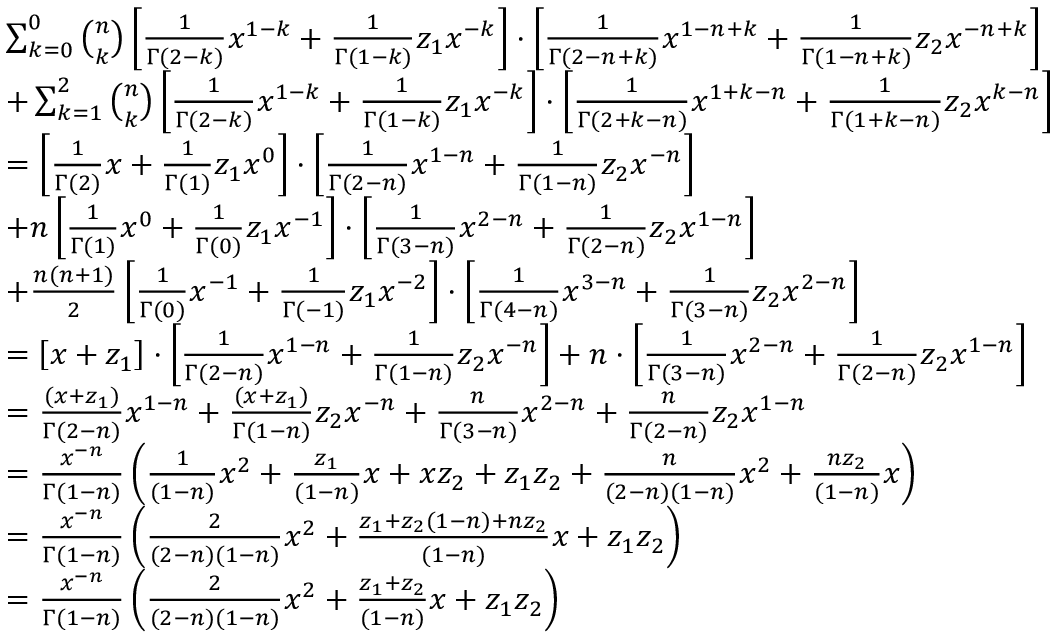Convert formula to latex. <formula><loc_0><loc_0><loc_500><loc_500>\begin{array} { r l } & { \sum _ { k = 0 } ^ { 0 } \binom { n } { k } \left [ \frac { 1 } { \Gamma ( 2 - k ) } x ^ { 1 - k } + \frac { 1 } { \Gamma ( 1 - k ) } z _ { 1 } x ^ { - k } \right ] \cdot \left [ \frac { 1 } { \Gamma ( 2 - n + k ) } x ^ { 1 - n + k } + \frac { 1 } { \Gamma ( 1 - n + k ) } z _ { 2 } x ^ { - n + k } \right ] } \\ & { + \sum _ { k = 1 } ^ { 2 } \binom { n } { k } \left [ \frac { 1 } { \Gamma ( 2 - k ) } x ^ { 1 - k } + \frac { 1 } { \Gamma ( 1 - k ) } z _ { 1 } x ^ { - k } \right ] \cdot \left [ \frac { 1 } { \Gamma ( 2 + k - n ) } x ^ { 1 + k - n } + \frac { 1 } { \Gamma ( 1 + k - n ) } z _ { 2 } x ^ { k - n } \right ] } \\ & { = \left [ \frac { 1 } { \Gamma ( 2 ) } x + \frac { 1 } { \Gamma ( 1 ) } z _ { 1 } x ^ { 0 } \right ] \cdot \left [ \frac { 1 } { \Gamma ( 2 - n ) } x ^ { 1 - n } + \frac { 1 } { \Gamma ( 1 - n ) } z _ { 2 } x ^ { - n } \right ] } \\ & { + n \left [ \frac { 1 } { \Gamma ( 1 ) } x ^ { 0 } + \frac { 1 } { \Gamma ( 0 ) } z _ { 1 } x ^ { - 1 } \right ] \cdot \left [ \frac { 1 } { \Gamma ( 3 - n ) } x ^ { 2 - n } + \frac { 1 } { \Gamma ( 2 - n ) } z _ { 2 } x ^ { 1 - n } \right ] } \\ & { + \frac { n ( n + 1 ) } { 2 } \left [ \frac { 1 } { \Gamma ( 0 ) } x ^ { - 1 } + \frac { 1 } { \Gamma ( - 1 ) } z _ { 1 } x ^ { - 2 } \right ] \cdot \left [ \frac { 1 } { \Gamma ( 4 - n ) } x ^ { 3 - n } + \frac { 1 } { \Gamma ( 3 - n ) } z _ { 2 } x ^ { 2 - n } \right ] } \\ & { = \left [ x + z _ { 1 } \right ] \cdot \left [ \frac { 1 } { \Gamma ( 2 - n ) } x ^ { 1 - n } + \frac { 1 } { \Gamma ( 1 - n ) } z _ { 2 } x ^ { - n } \right ] + n \cdot \left [ \frac { 1 } { \Gamma ( 3 - n ) } x ^ { 2 - n } + \frac { 1 } { \Gamma ( 2 - n ) } z _ { 2 } x ^ { 1 - n } \right ] } \\ & { = \frac { ( x + z _ { 1 } ) } { \Gamma ( 2 - n ) } x ^ { 1 - n } + \frac { ( x + z _ { 1 } ) } { \Gamma ( 1 - n ) } z _ { 2 } x ^ { - n } + \frac { n } { \Gamma ( 3 - n ) } x ^ { 2 - n } + \frac { n } { \Gamma ( 2 - n ) } z _ { 2 } x ^ { 1 - n } } \\ & { = \frac { x ^ { - n } } { \Gamma ( 1 - n ) } \left ( \frac { 1 } { ( 1 - n ) } x ^ { 2 } + \frac { z _ { 1 } } { ( 1 - n ) } x + x z _ { 2 } + z _ { 1 } z _ { 2 } + \frac { n } { ( 2 - n ) ( 1 - n ) } x ^ { 2 } + \frac { n z _ { 2 } } { ( 1 - n ) } x \right ) } \\ & { = \frac { x ^ { - n } } { \Gamma ( 1 - n ) } \left ( \frac { 2 } { ( 2 - n ) ( 1 - n ) } x ^ { 2 } + \frac { z _ { 1 } + z _ { 2 } ( 1 - n ) + n z _ { 2 } } { ( 1 - n ) } x + z _ { 1 } z _ { 2 } \right ) } \\ & { = \frac { x ^ { - n } } { \Gamma ( 1 - n ) } \left ( \frac { 2 } { ( 2 - n ) ( 1 - n ) } x ^ { 2 } + \frac { z _ { 1 } + z _ { 2 } } { ( 1 - n ) } x + z _ { 1 } z _ { 2 } \right ) } \end{array}</formula> 